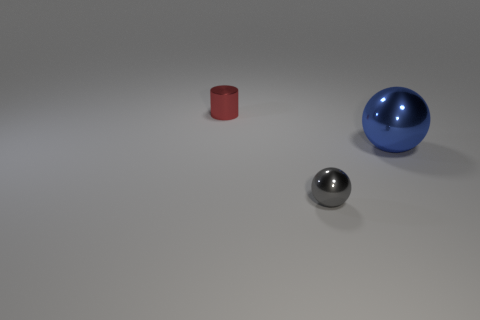There is a cylinder; is its size the same as the metallic object right of the gray shiny ball?
Give a very brief answer. No. Are there any balls in front of the metallic thing on the right side of the gray ball?
Provide a short and direct response. Yes. Is there another metal object of the same shape as the blue object?
Your response must be concise. Yes. How many objects are behind the ball to the right of the small shiny thing that is right of the red metal object?
Provide a short and direct response. 1. How many objects are either things behind the large blue metallic sphere or small shiny objects that are in front of the large thing?
Provide a succinct answer. 2. Is the number of small metal objects on the left side of the tiny gray shiny ball greater than the number of tiny red shiny cylinders right of the small metallic cylinder?
Your answer should be compact. Yes. What is the material of the object right of the sphere in front of the ball behind the gray shiny object?
Ensure brevity in your answer.  Metal. There is a tiny thing in front of the big blue thing; does it have the same shape as the metal thing that is right of the tiny sphere?
Your answer should be very brief. Yes. Is there a gray metallic object of the same size as the gray shiny ball?
Offer a terse response. No. What number of gray things are either small things or tiny cylinders?
Your answer should be very brief. 1. 